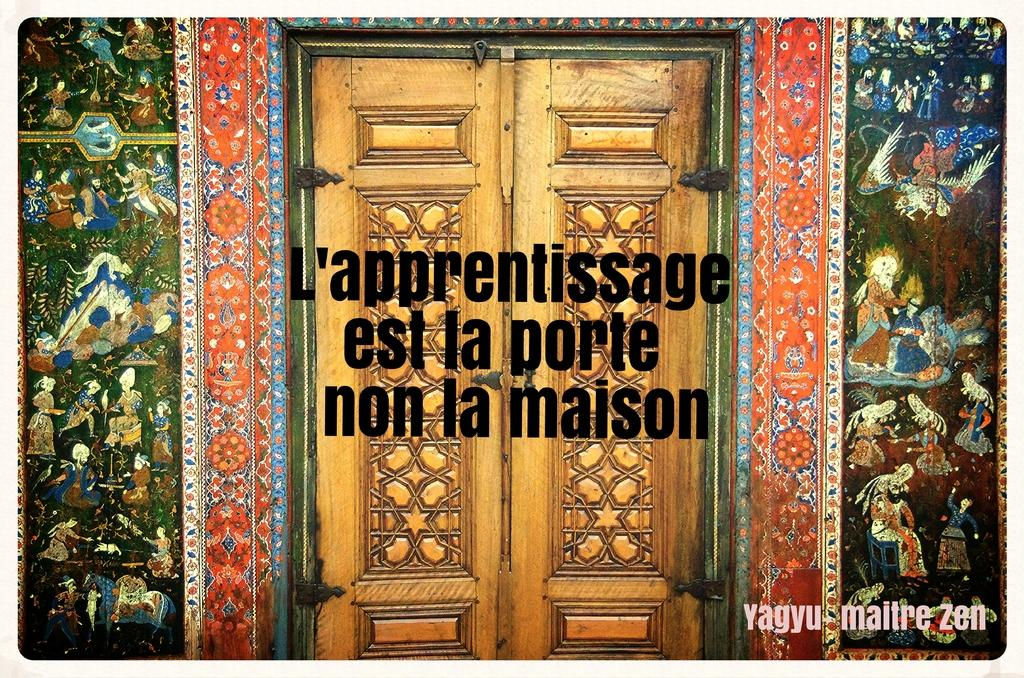What is the main subject of the image? The main subject of the image is a poster. What can be seen on the poster? The poster contains walls with paintings and a door. Is there any text present on the poster? Yes, there is text written in the middle of the image. How many clocks are hanging on the walls in the image? There are no clocks visible in the image; the poster only contains walls with paintings and a door. Is there a bed featured in the poster? No, there is no bed present in the image; the poster only contains walls with paintings, a door, and text. 